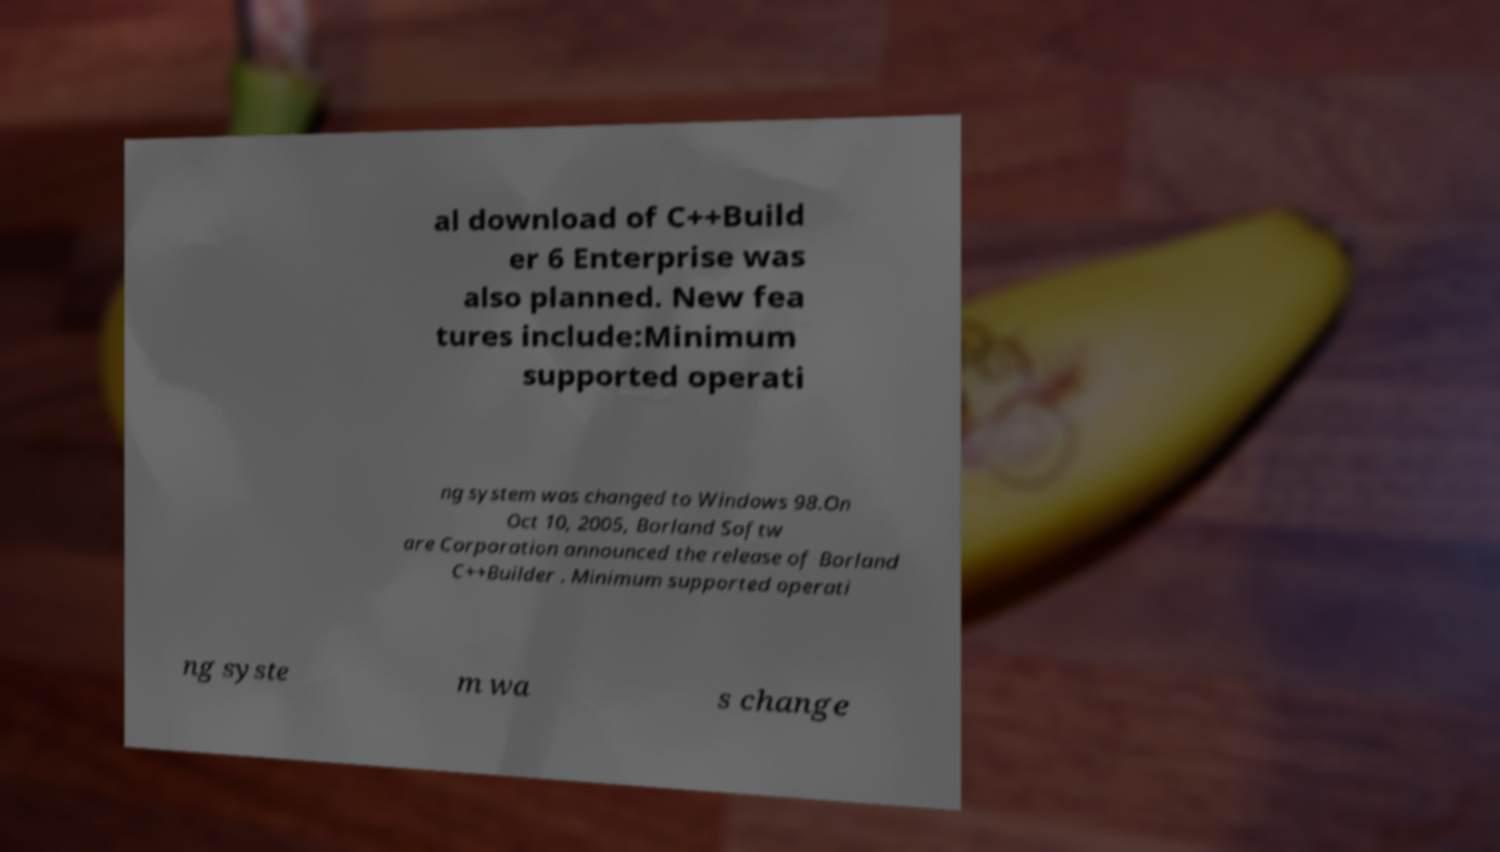Could you extract and type out the text from this image? al download of C++Build er 6 Enterprise was also planned. New fea tures include:Minimum supported operati ng system was changed to Windows 98.On Oct 10, 2005, Borland Softw are Corporation announced the release of Borland C++Builder . Minimum supported operati ng syste m wa s change 